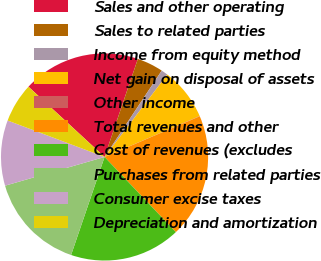Convert chart. <chart><loc_0><loc_0><loc_500><loc_500><pie_chart><fcel>Sales and other operating<fcel>Sales to related parties<fcel>Income from equity method<fcel>Net gain on disposal of assets<fcel>Other income<fcel>Total revenues and other<fcel>Cost of revenues (excludes<fcel>Purchases from related parties<fcel>Consumer excise taxes<fcel>Depreciation and amortization<nl><fcel>18.34%<fcel>4.1%<fcel>1.05%<fcel>8.17%<fcel>0.04%<fcel>19.35%<fcel>17.32%<fcel>15.29%<fcel>10.2%<fcel>6.14%<nl></chart> 